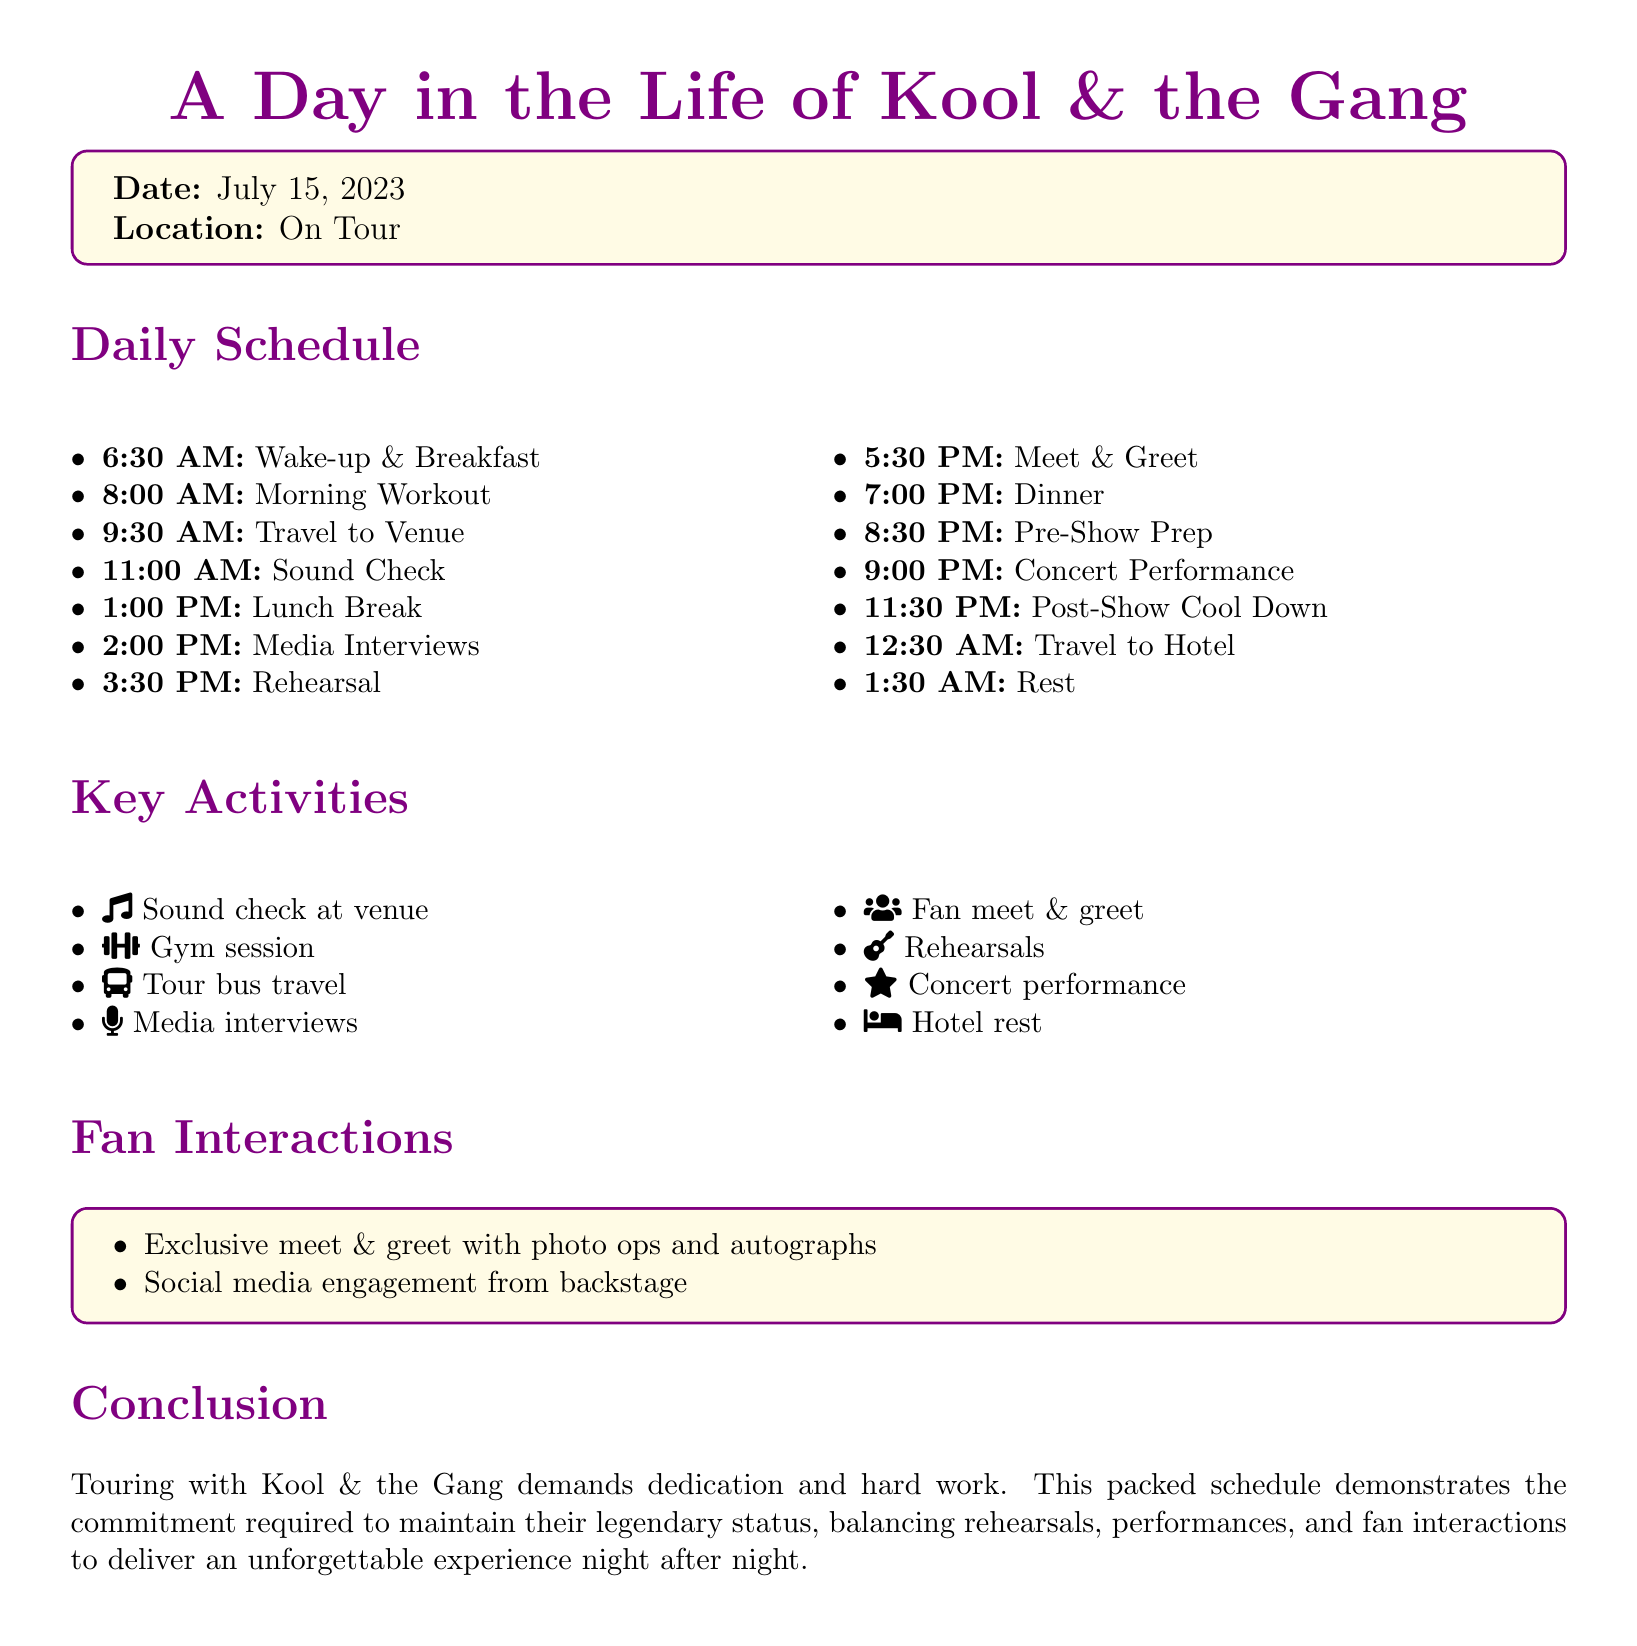What time does the day start for Kool & the Gang? The day starts at 6:30 AM with wake-up and breakfast.
Answer: 6:30 AM What activity is scheduled right after lunch? After lunch, media interviews are scheduled at 2:00 PM.
Answer: Media Interviews How long is the cool down period after the concert? The post-show cool down takes half an hour, from 11:30 PM to 12:00 AM.
Answer: 30 minutes What does the band do at 5:30 PM? At 5:30 PM, there is a meet & greet session.
Answer: Meet & Greet How many hours of rest are planned after returning to the hotel? The rest planned after traveling to the hotel is seven hours, from 1:30 AM to 6:30 AM.
Answer: 7 hours What type of fan interaction is mentioned in the document? Exclusive meet and greet with photo opportunities and autographs is mentioned.
Answer: Exclusive meet & greet What is the main focus of the conclusion section? The conclusion emphasizes the dedication and hard work required to maintain Kool & the Gang's legendary status while touring.
Answer: Dedication and hard work What is the first scheduled activity of the day? The first activity is wake-up and breakfast.
Answer: Wake-up & Breakfast At what time is the concert performance scheduled? The concert performance is scheduled for 9:00 PM.
Answer: 9:00 PM 